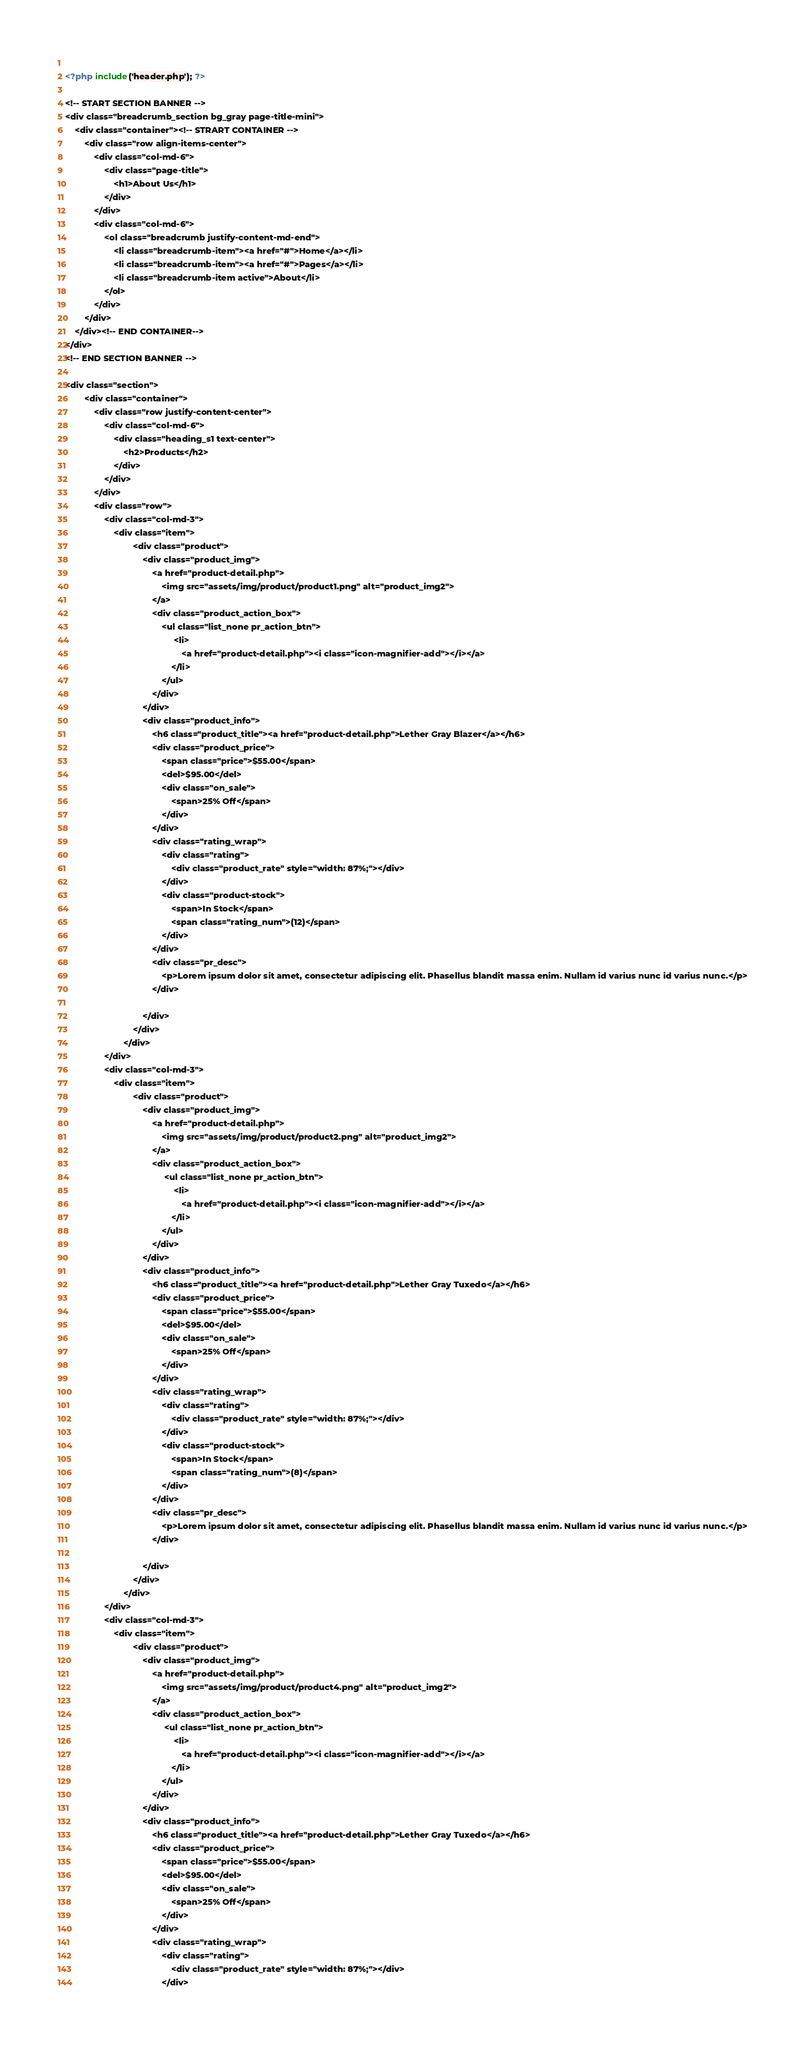Convert code to text. <code><loc_0><loc_0><loc_500><loc_500><_PHP_>        
<?php include('header.php'); ?>

<!-- START SECTION BANNER -->
<div class="breadcrumb_section bg_gray page-title-mini">
    <div class="container"><!-- STRART CONTAINER -->
        <div class="row align-items-center">
            <div class="col-md-6">
                <div class="page-title">
                    <h1>About Us</h1>
                </div>
            </div>
            <div class="col-md-6">
                <ol class="breadcrumb justify-content-md-end">
                    <li class="breadcrumb-item"><a href="#">Home</a></li>
                    <li class="breadcrumb-item"><a href="#">Pages</a></li>
                    <li class="breadcrumb-item active">About</li>
                </ol>
            </div>
        </div>
    </div><!-- END CONTAINER-->
</div>
<!-- END SECTION BANNER -->

<div class="section">
        <div class="container">
            <div class="row justify-content-center">
                <div class="col-md-6">
                    <div class="heading_s1 text-center">
                        <h2>Products</h2>
                    </div>
                </div>
            </div>
            <div class="row">
                <div class="col-md-3">
                    <div class="item">
                            <div class="product">
                                <div class="product_img">
                                    <a href="product-detail.php">
                                        <img src="assets/img/product/product1.png" alt="product_img2">
                                    </a>
                                    <div class="product_action_box">
                                        <ul class="list_none pr_action_btn">
                                             <li>
                                                <a href="product-detail.php"><i class="icon-magnifier-add"></i></a>
                                            </li>
                                        </ul>
                                    </div>
                                </div>
                                <div class="product_info">
                                    <h6 class="product_title"><a href="product-detail.php">Lether Gray Blazer</a></h6>
                                    <div class="product_price">
                                        <span class="price">$55.00</span>
                                        <del>$95.00</del>
                                        <div class="on_sale">
                                            <span>25% Off</span>
                                        </div>
                                    </div>
                                    <div class="rating_wrap">
                                        <div class="rating">
                                            <div class="product_rate" style="width: 87%;"></div>
                                        </div>
                                        <div class="product-stock">
                                            <span>In Stock</span>
                                            <span class="rating_num">(12)</span>
                                        </div>
                                    </div>
                                    <div class="pr_desc">
                                        <p>Lorem ipsum dolor sit amet, consectetur adipiscing elit. Phasellus blandit massa enim. Nullam id varius nunc id varius nunc.</p>
                                    </div>
                                    
                                </div>
                            </div>
                        </div>
                </div>
                <div class="col-md-3">
                    <div class="item">
                            <div class="product">
                                <div class="product_img">
                                    <a href="product-detail.php">
                                        <img src="assets/img/product/product2.png" alt="product_img2">
                                    </a>
                                    <div class="product_action_box">
                                         <ul class="list_none pr_action_btn">
                                             <li>
                                                <a href="product-detail.php"><i class="icon-magnifier-add"></i></a>
                                            </li>
                                        </ul>
                                    </div>
                                </div>
                                <div class="product_info">
                                    <h6 class="product_title"><a href="product-detail.php">Lether Gray Tuxedo</a></h6>
                                    <div class="product_price">
                                        <span class="price">$55.00</span>
                                        <del>$95.00</del>
                                        <div class="on_sale">
                                            <span>25% Off</span>
                                        </div>
                                    </div>
                                    <div class="rating_wrap">
                                        <div class="rating">
                                            <div class="product_rate" style="width: 87%;"></div>
                                        </div>
                                        <div class="product-stock">
                                            <span>In Stock</span>
                                            <span class="rating_num">(8)</span>
                                        </div>
                                    </div>
                                    <div class="pr_desc">
                                        <p>Lorem ipsum dolor sit amet, consectetur adipiscing elit. Phasellus blandit massa enim. Nullam id varius nunc id varius nunc.</p>
                                    </div>
                                    
                                </div>
                            </div>
                        </div>
                </div>
                <div class="col-md-3">
                    <div class="item">
                            <div class="product">
                                <div class="product_img">
                                    <a href="product-detail.php">
                                        <img src="assets/img/product/product4.png" alt="product_img2">
                                    </a>
                                    <div class="product_action_box">
                                         <ul class="list_none pr_action_btn">
                                             <li>
                                                <a href="product-detail.php"><i class="icon-magnifier-add"></i></a>
                                            </li>
                                        </ul>
                                    </div>
                                </div>
                                <div class="product_info">
                                    <h6 class="product_title"><a href="product-detail.php">Lether Gray Tuxedo</a></h6>
                                    <div class="product_price">
                                        <span class="price">$55.00</span>
                                        <del>$95.00</del>
                                        <div class="on_sale">
                                            <span>25% Off</span>
                                        </div>
                                    </div>
                                    <div class="rating_wrap">
                                        <div class="rating">
                                            <div class="product_rate" style="width: 87%;"></div>
                                        </div></code> 